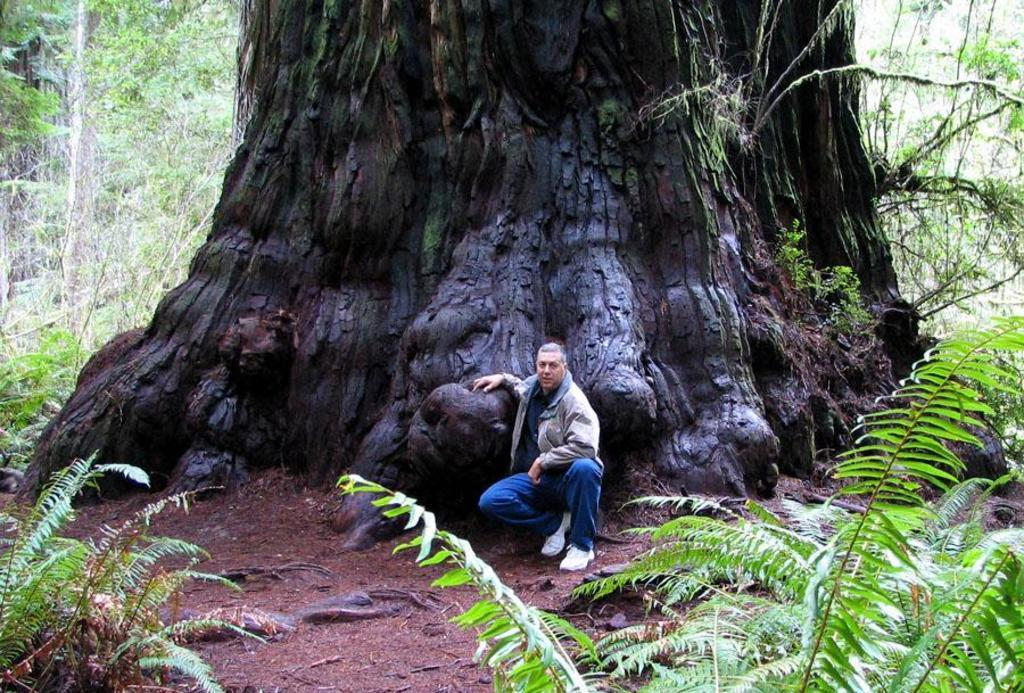What is located in the foreground of the image? There are plants, soil, and roots visible in the foreground of the image. What can be seen near the plants in the foreground? There is a person standing near a huge tree trunk in the image. Where is the tree trunk located in the image? The tree trunk is in the center of the image. What is visible in the background of the image? There are plants and trees present in the background of the image. What type of blade is being used to cut the fact in the image? There is no blade or fact present in the image; it features plants, soil, roots, a person, and trees. 